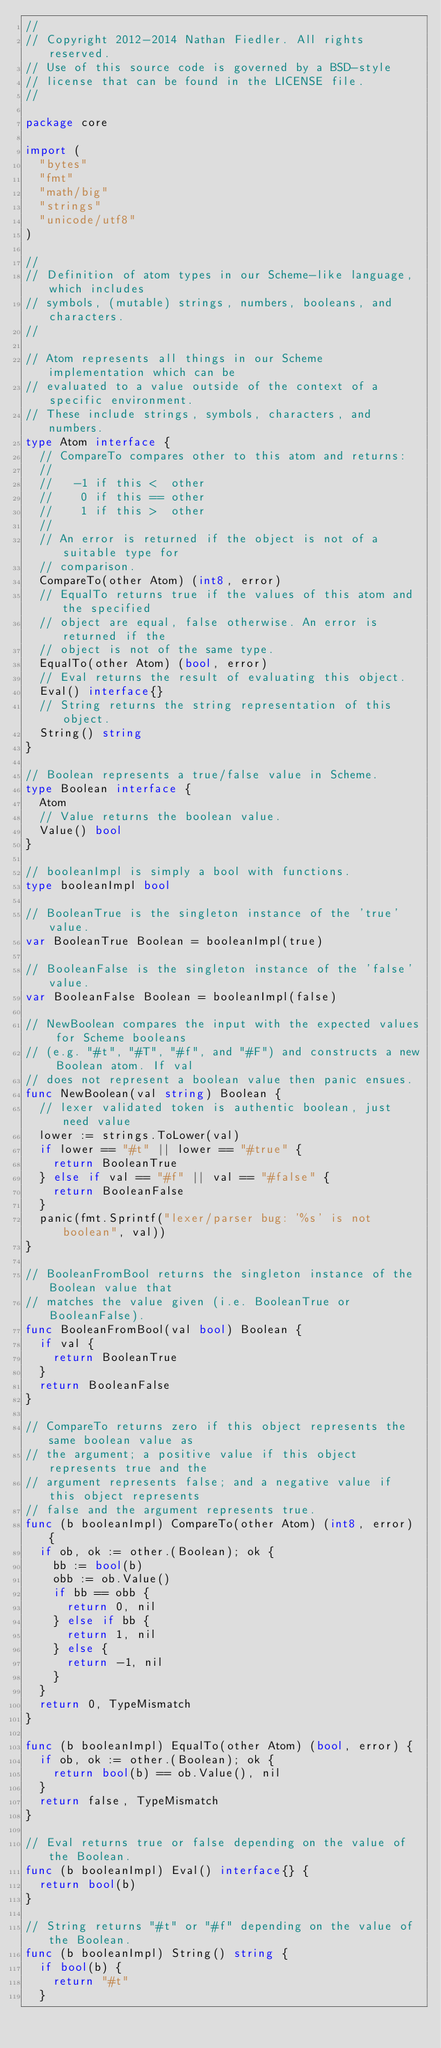<code> <loc_0><loc_0><loc_500><loc_500><_Go_>//
// Copyright 2012-2014 Nathan Fiedler. All rights reserved.
// Use of this source code is governed by a BSD-style
// license that can be found in the LICENSE file.
//

package core

import (
	"bytes"
	"fmt"
	"math/big"
	"strings"
	"unicode/utf8"
)

//
// Definition of atom types in our Scheme-like language, which includes
// symbols, (mutable) strings, numbers, booleans, and characters.
//

// Atom represents all things in our Scheme implementation which can be
// evaluated to a value outside of the context of a specific environment.
// These include strings, symbols, characters, and numbers.
type Atom interface {
	// CompareTo compares other to this atom and returns:
	//
	//   -1 if this <  other
	//    0 if this == other
	//    1 if this >  other
	//
	// An error is returned if the object is not of a suitable type for
	// comparison.
	CompareTo(other Atom) (int8, error)
	// EqualTo returns true if the values of this atom and the specified
	// object are equal, false otherwise. An error is returned if the
	// object is not of the same type.
	EqualTo(other Atom) (bool, error)
	// Eval returns the result of evaluating this object.
	Eval() interface{}
	// String returns the string representation of this object.
	String() string
}

// Boolean represents a true/false value in Scheme.
type Boolean interface {
	Atom
	// Value returns the boolean value.
	Value() bool
}

// booleanImpl is simply a bool with functions.
type booleanImpl bool

// BooleanTrue is the singleton instance of the 'true' value.
var BooleanTrue Boolean = booleanImpl(true)

// BooleanFalse is the singleton instance of the 'false' value.
var BooleanFalse Boolean = booleanImpl(false)

// NewBoolean compares the input with the expected values for Scheme booleans
// (e.g. "#t", "#T", "#f", and "#F") and constructs a new Boolean atom. If val
// does not represent a boolean value then panic ensues.
func NewBoolean(val string) Boolean {
	// lexer validated token is authentic boolean, just need value
	lower := strings.ToLower(val)
	if lower == "#t" || lower == "#true" {
		return BooleanTrue
	} else if val == "#f" || val == "#false" {
		return BooleanFalse
	}
	panic(fmt.Sprintf("lexer/parser bug: '%s' is not boolean", val))
}

// BooleanFromBool returns the singleton instance of the Boolean value that
// matches the value given (i.e. BooleanTrue or BooleanFalse).
func BooleanFromBool(val bool) Boolean {
	if val {
		return BooleanTrue
	}
	return BooleanFalse
}

// CompareTo returns zero if this object represents the same boolean value as
// the argument; a positive value if this object represents true and the
// argument represents false; and a negative value if this object represents
// false and the argument represents true.
func (b booleanImpl) CompareTo(other Atom) (int8, error) {
	if ob, ok := other.(Boolean); ok {
		bb := bool(b)
		obb := ob.Value()
		if bb == obb {
			return 0, nil
		} else if bb {
			return 1, nil
		} else {
			return -1, nil
		}
	}
	return 0, TypeMismatch
}

func (b booleanImpl) EqualTo(other Atom) (bool, error) {
	if ob, ok := other.(Boolean); ok {
		return bool(b) == ob.Value(), nil
	}
	return false, TypeMismatch
}

// Eval returns true or false depending on the value of the Boolean.
func (b booleanImpl) Eval() interface{} {
	return bool(b)
}

// String returns "#t" or "#f" depending on the value of the Boolean.
func (b booleanImpl) String() string {
	if bool(b) {
		return "#t"
	}</code> 